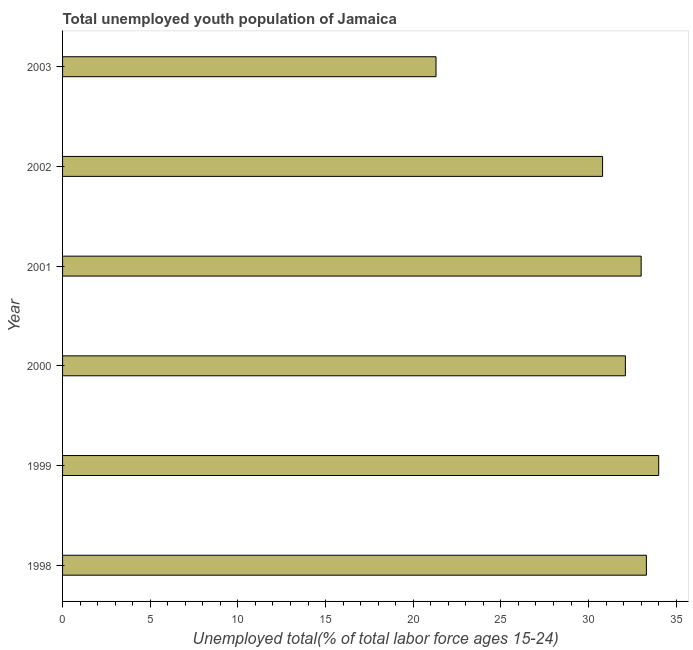Does the graph contain grids?
Keep it short and to the point. No. What is the title of the graph?
Ensure brevity in your answer.  Total unemployed youth population of Jamaica. What is the label or title of the X-axis?
Give a very brief answer. Unemployed total(% of total labor force ages 15-24). What is the unemployed youth in 1999?
Make the answer very short. 34. Across all years, what is the minimum unemployed youth?
Your response must be concise. 21.3. In which year was the unemployed youth maximum?
Your answer should be very brief. 1999. What is the sum of the unemployed youth?
Your response must be concise. 184.5. What is the difference between the unemployed youth in 2001 and 2002?
Your response must be concise. 2.2. What is the average unemployed youth per year?
Offer a very short reply. 30.75. What is the median unemployed youth?
Provide a short and direct response. 32.55. In how many years, is the unemployed youth greater than 23 %?
Offer a very short reply. 5. Do a majority of the years between 2002 and 1999 (inclusive) have unemployed youth greater than 8 %?
Provide a short and direct response. Yes. What is the ratio of the unemployed youth in 2000 to that in 2002?
Provide a short and direct response. 1.04. What is the difference between the highest and the second highest unemployed youth?
Make the answer very short. 0.7. Is the sum of the unemployed youth in 2001 and 2003 greater than the maximum unemployed youth across all years?
Your answer should be compact. Yes. What is the difference between the highest and the lowest unemployed youth?
Give a very brief answer. 12.7. In how many years, is the unemployed youth greater than the average unemployed youth taken over all years?
Offer a very short reply. 5. How many bars are there?
Keep it short and to the point. 6. Are all the bars in the graph horizontal?
Your answer should be very brief. Yes. Are the values on the major ticks of X-axis written in scientific E-notation?
Provide a succinct answer. No. What is the Unemployed total(% of total labor force ages 15-24) of 1998?
Your answer should be compact. 33.3. What is the Unemployed total(% of total labor force ages 15-24) in 1999?
Give a very brief answer. 34. What is the Unemployed total(% of total labor force ages 15-24) in 2000?
Keep it short and to the point. 32.1. What is the Unemployed total(% of total labor force ages 15-24) of 2001?
Provide a succinct answer. 33. What is the Unemployed total(% of total labor force ages 15-24) of 2002?
Make the answer very short. 30.8. What is the Unemployed total(% of total labor force ages 15-24) in 2003?
Provide a succinct answer. 21.3. What is the difference between the Unemployed total(% of total labor force ages 15-24) in 1998 and 1999?
Give a very brief answer. -0.7. What is the difference between the Unemployed total(% of total labor force ages 15-24) in 1998 and 2000?
Your answer should be very brief. 1.2. What is the difference between the Unemployed total(% of total labor force ages 15-24) in 1999 and 2000?
Your answer should be compact. 1.9. What is the difference between the Unemployed total(% of total labor force ages 15-24) in 2000 and 2003?
Provide a succinct answer. 10.8. What is the difference between the Unemployed total(% of total labor force ages 15-24) in 2001 and 2002?
Keep it short and to the point. 2.2. What is the difference between the Unemployed total(% of total labor force ages 15-24) in 2001 and 2003?
Provide a short and direct response. 11.7. What is the difference between the Unemployed total(% of total labor force ages 15-24) in 2002 and 2003?
Offer a terse response. 9.5. What is the ratio of the Unemployed total(% of total labor force ages 15-24) in 1998 to that in 2000?
Your answer should be compact. 1.04. What is the ratio of the Unemployed total(% of total labor force ages 15-24) in 1998 to that in 2002?
Give a very brief answer. 1.08. What is the ratio of the Unemployed total(% of total labor force ages 15-24) in 1998 to that in 2003?
Offer a terse response. 1.56. What is the ratio of the Unemployed total(% of total labor force ages 15-24) in 1999 to that in 2000?
Provide a short and direct response. 1.06. What is the ratio of the Unemployed total(% of total labor force ages 15-24) in 1999 to that in 2002?
Your answer should be compact. 1.1. What is the ratio of the Unemployed total(% of total labor force ages 15-24) in 1999 to that in 2003?
Give a very brief answer. 1.6. What is the ratio of the Unemployed total(% of total labor force ages 15-24) in 2000 to that in 2002?
Offer a terse response. 1.04. What is the ratio of the Unemployed total(% of total labor force ages 15-24) in 2000 to that in 2003?
Keep it short and to the point. 1.51. What is the ratio of the Unemployed total(% of total labor force ages 15-24) in 2001 to that in 2002?
Give a very brief answer. 1.07. What is the ratio of the Unemployed total(% of total labor force ages 15-24) in 2001 to that in 2003?
Provide a succinct answer. 1.55. What is the ratio of the Unemployed total(% of total labor force ages 15-24) in 2002 to that in 2003?
Your answer should be compact. 1.45. 